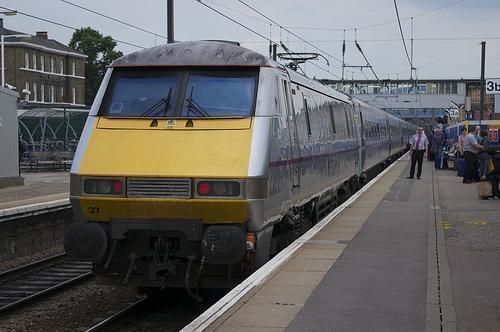How many people are facing the camera?
Give a very brief answer. 1. 